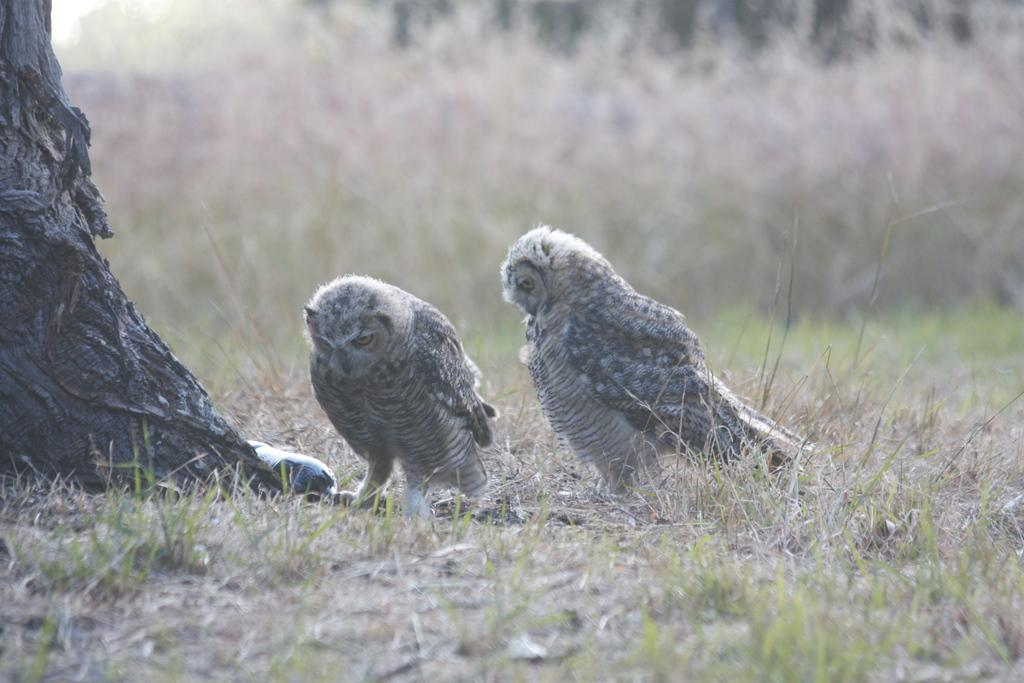How many owls are in the picture? There are two owls in the picture. What else can be seen in the picture besides the owls? There is a bottle in the picture. What is located on the left side of the picture? There is a tree on the left side of the picture. What can be seen in the background of the picture? There are plants in the background of the picture. Can you tell me which owl is using a rifle in the picture? There is no rifle present in the picture; it only features two owls, a bottle, a tree, and plants in the background. 